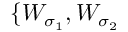Convert formula to latex. <formula><loc_0><loc_0><loc_500><loc_500>\{ W _ { \sigma _ { 1 } } , W _ { \sigma _ { 2 } }</formula> 